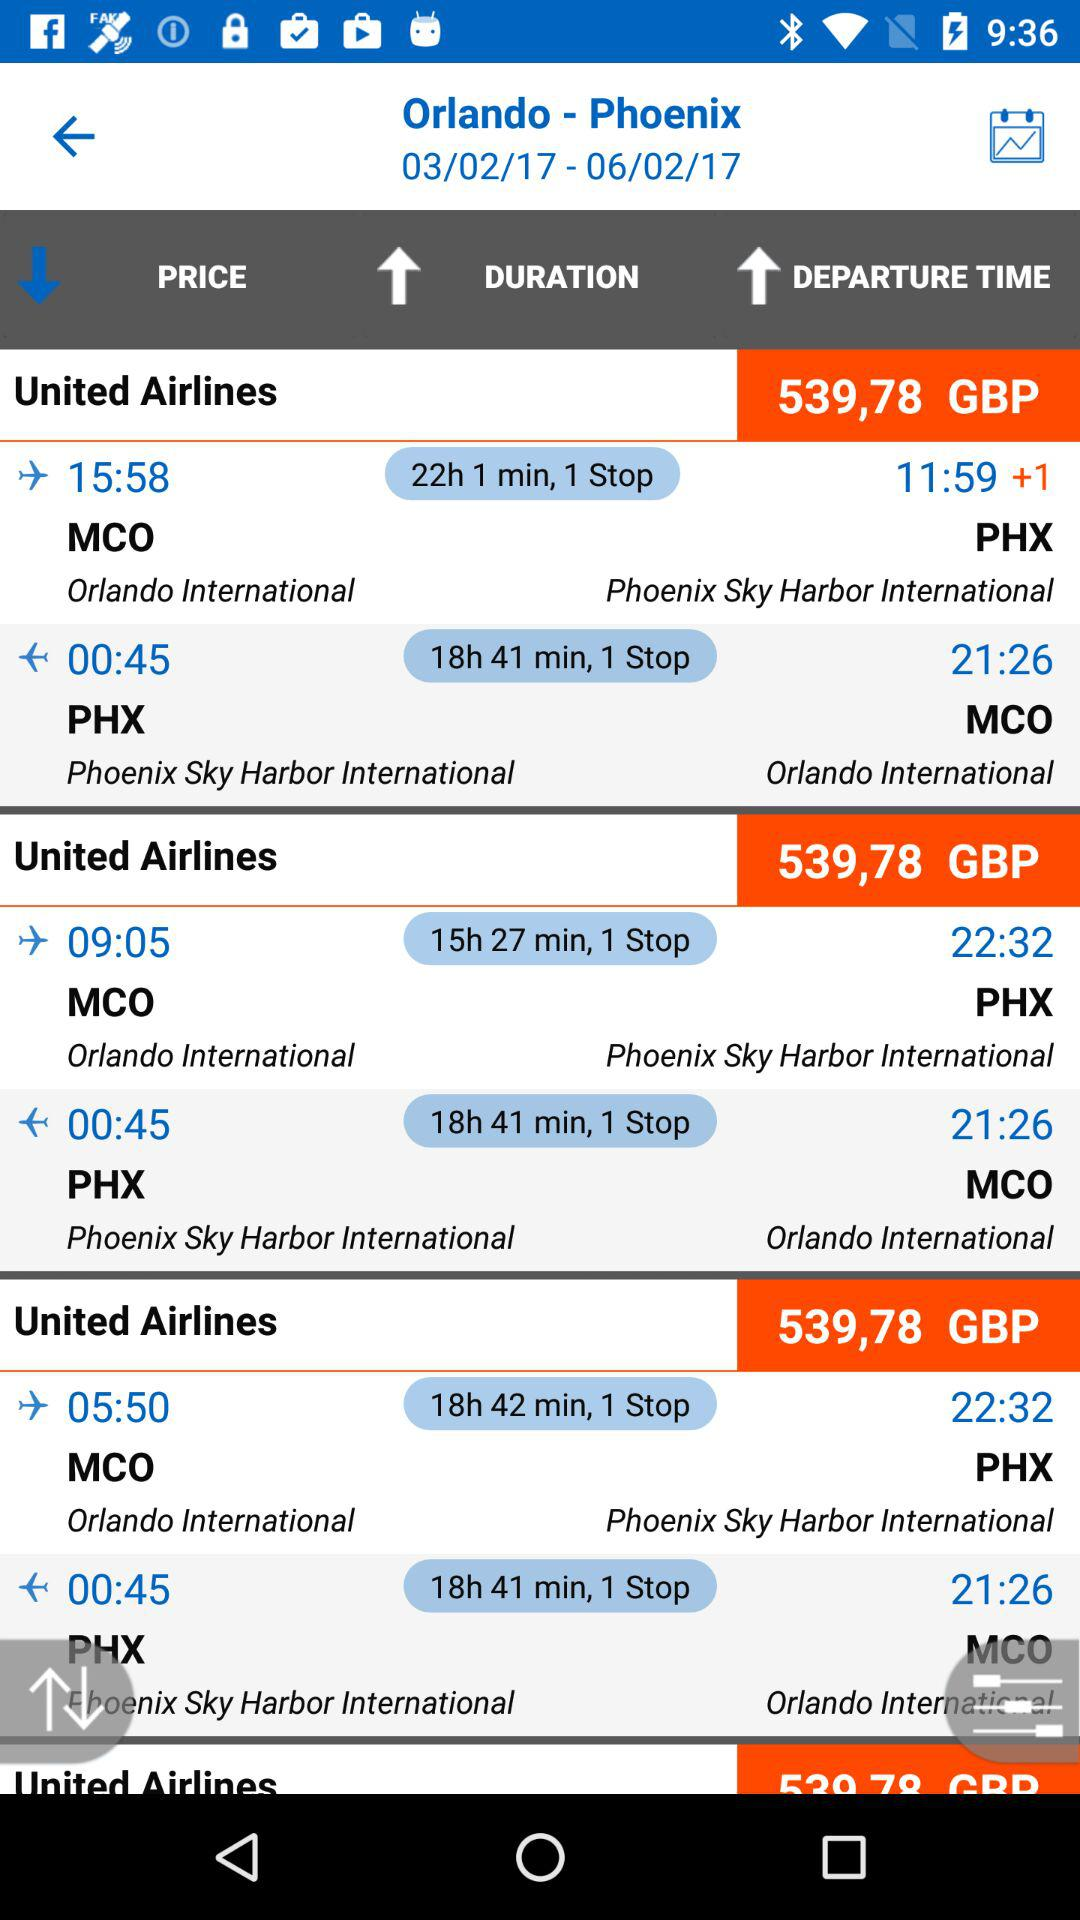Which flight duration is 18 hours 41 minutes? 18 hours 41 minutes is the duration of United Airlines. 